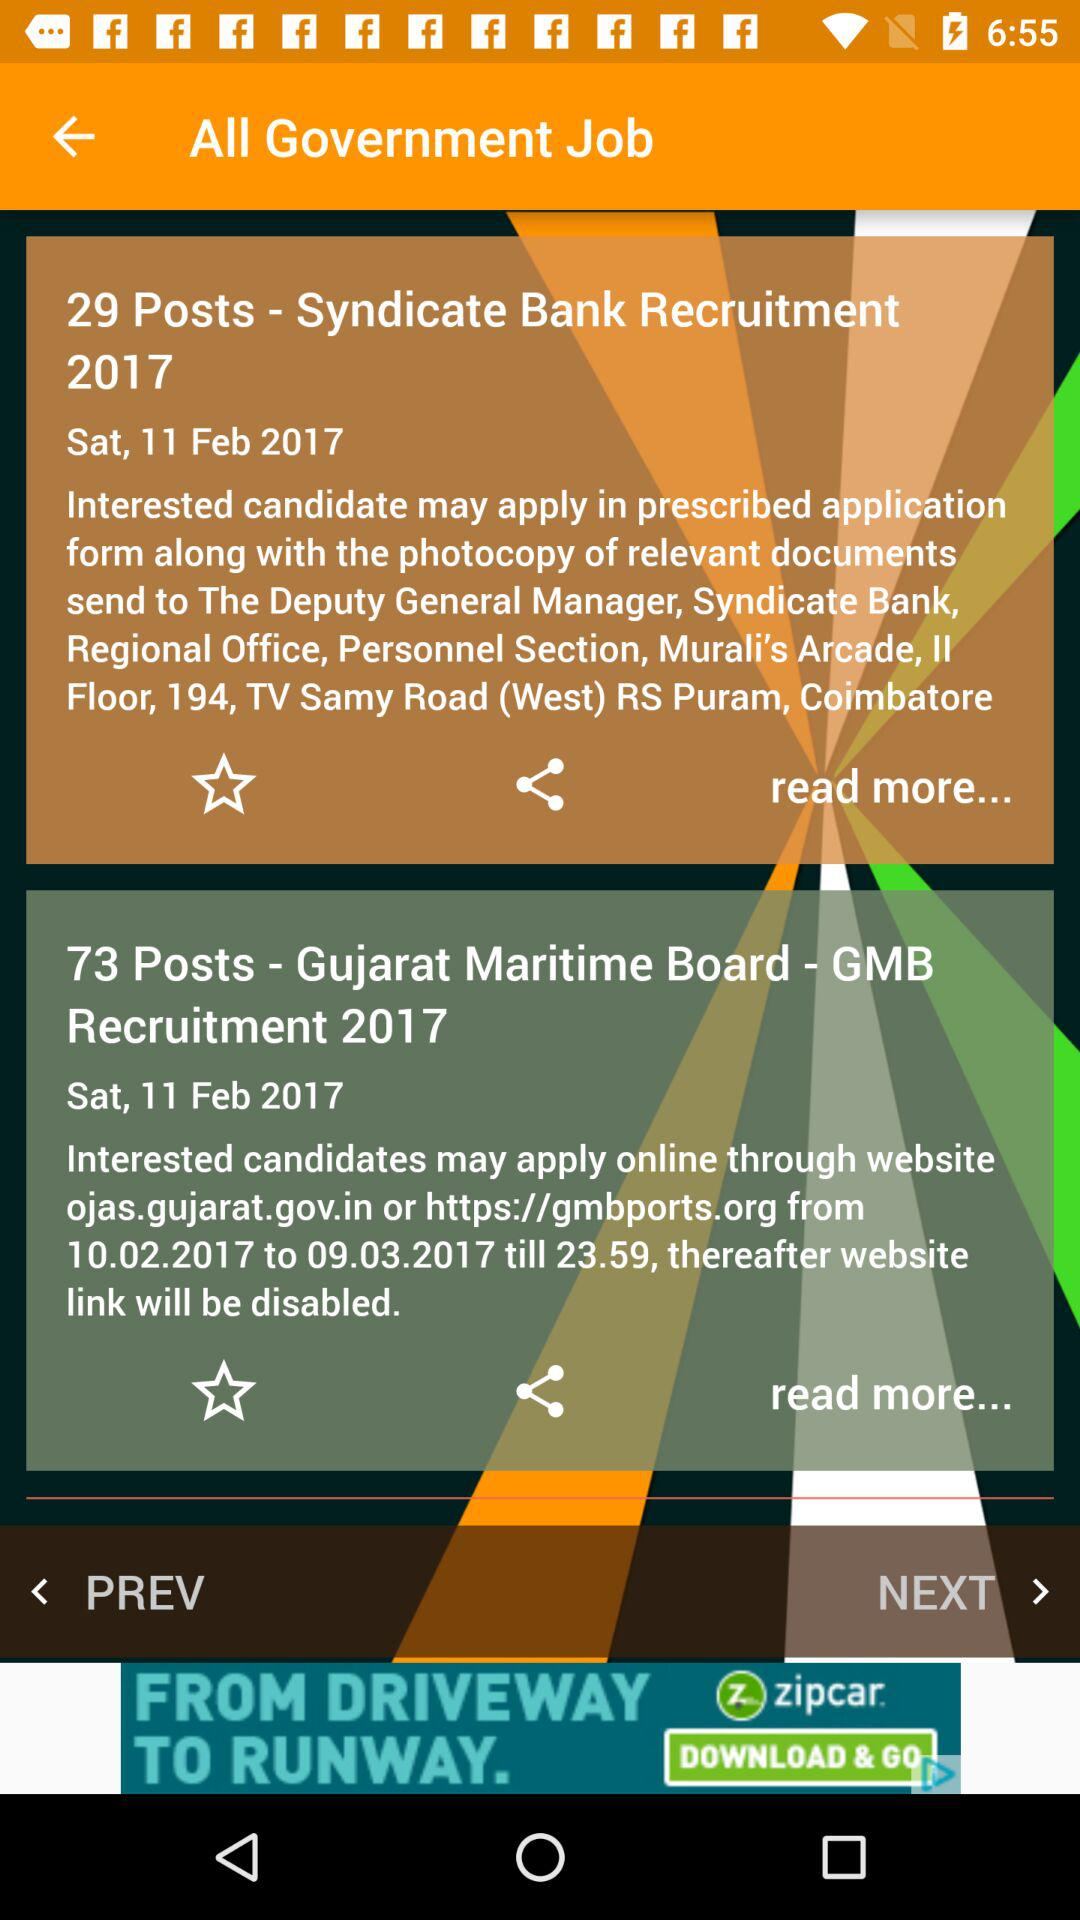At what times were the government jobs posted?
When the provided information is insufficient, respond with <no answer>. <no answer> 